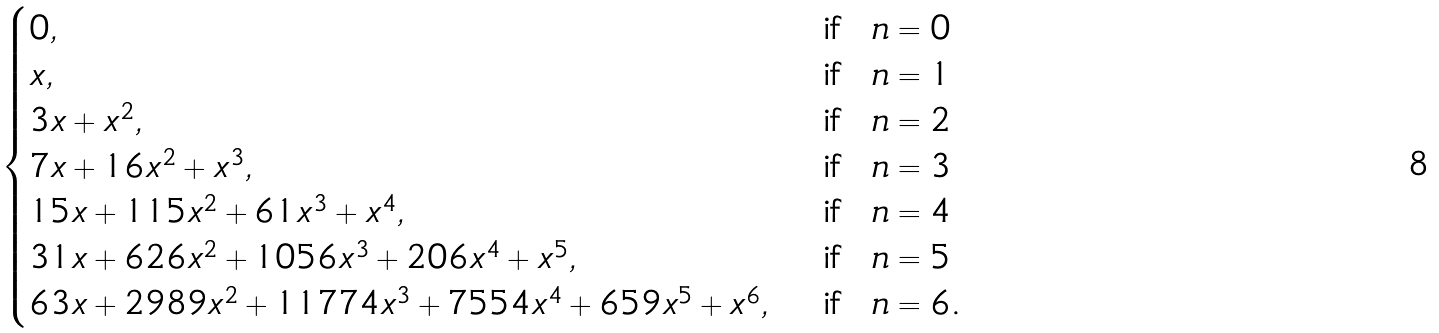Convert formula to latex. <formula><loc_0><loc_0><loc_500><loc_500>\begin{cases} 0 , & \ \text {if \ $n=0$} \\ x , & \ \text {if \ $n=1$} \\ 3 x + x ^ { 2 } , & \ \text {if \ $n=2$} \\ 7 x + 1 6 x ^ { 2 } + x ^ { 3 } , & \ \text {if \ $n=3$} \\ 1 5 x + 1 1 5 x ^ { 2 } + 6 1 x ^ { 3 } + x ^ { 4 } , & \ \text {if \ $n=4$} \\ 3 1 x + 6 2 6 x ^ { 2 } + 1 0 5 6 x ^ { 3 } + 2 0 6 x ^ { 4 } + x ^ { 5 } , & \ \text {if \ $n=5$} \\ 6 3 x + 2 9 8 9 x ^ { 2 } + 1 1 7 7 4 x ^ { 3 } + 7 5 5 4 x ^ { 4 } + 6 5 9 x ^ { 5 } + x ^ { 6 } , & \ \text {if \ $n=6$.} \end{cases}</formula> 